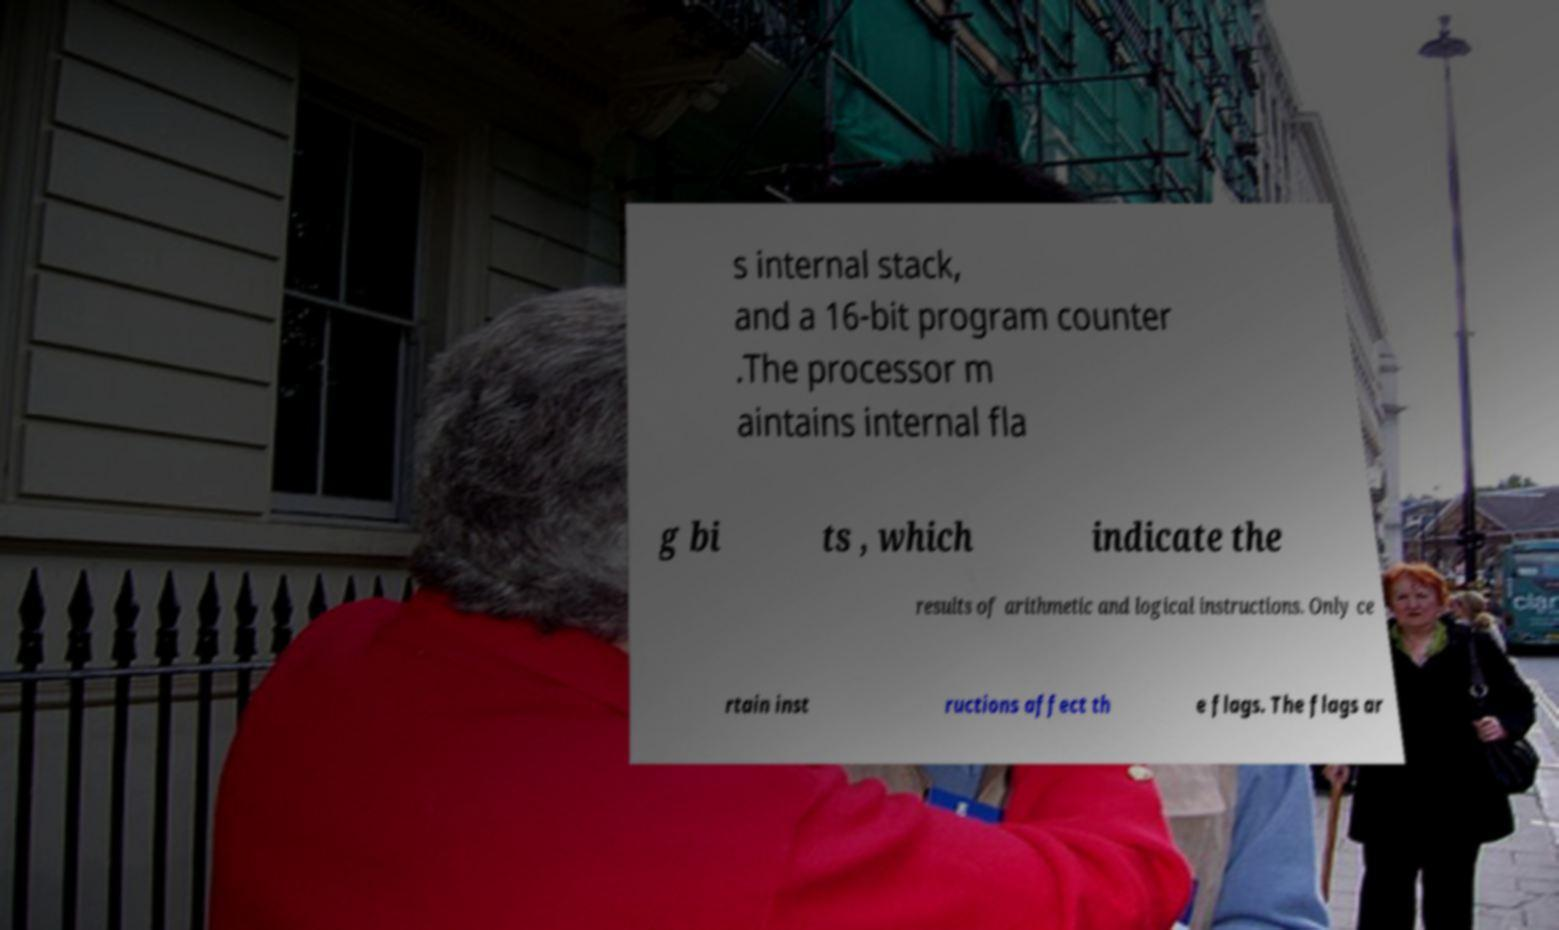Could you extract and type out the text from this image? s internal stack, and a 16-bit program counter .The processor m aintains internal fla g bi ts , which indicate the results of arithmetic and logical instructions. Only ce rtain inst ructions affect th e flags. The flags ar 